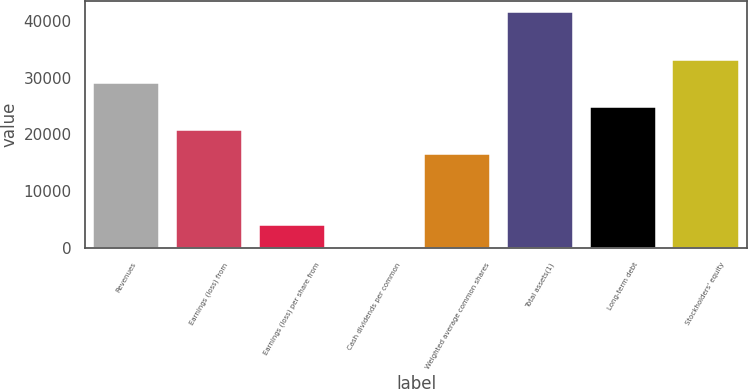<chart> <loc_0><loc_0><loc_500><loc_500><bar_chart><fcel>Revenues<fcel>Earnings (loss) from<fcel>Earnings (loss) per share from<fcel>Cash dividends per common<fcel>Weighted average common shares<fcel>Total assets(1)<fcel>Long-term debt<fcel>Stockholders' equity<nl><fcel>29019.3<fcel>20728.3<fcel>4146.1<fcel>0.56<fcel>16582.7<fcel>41456<fcel>24873.8<fcel>33164.9<nl></chart> 